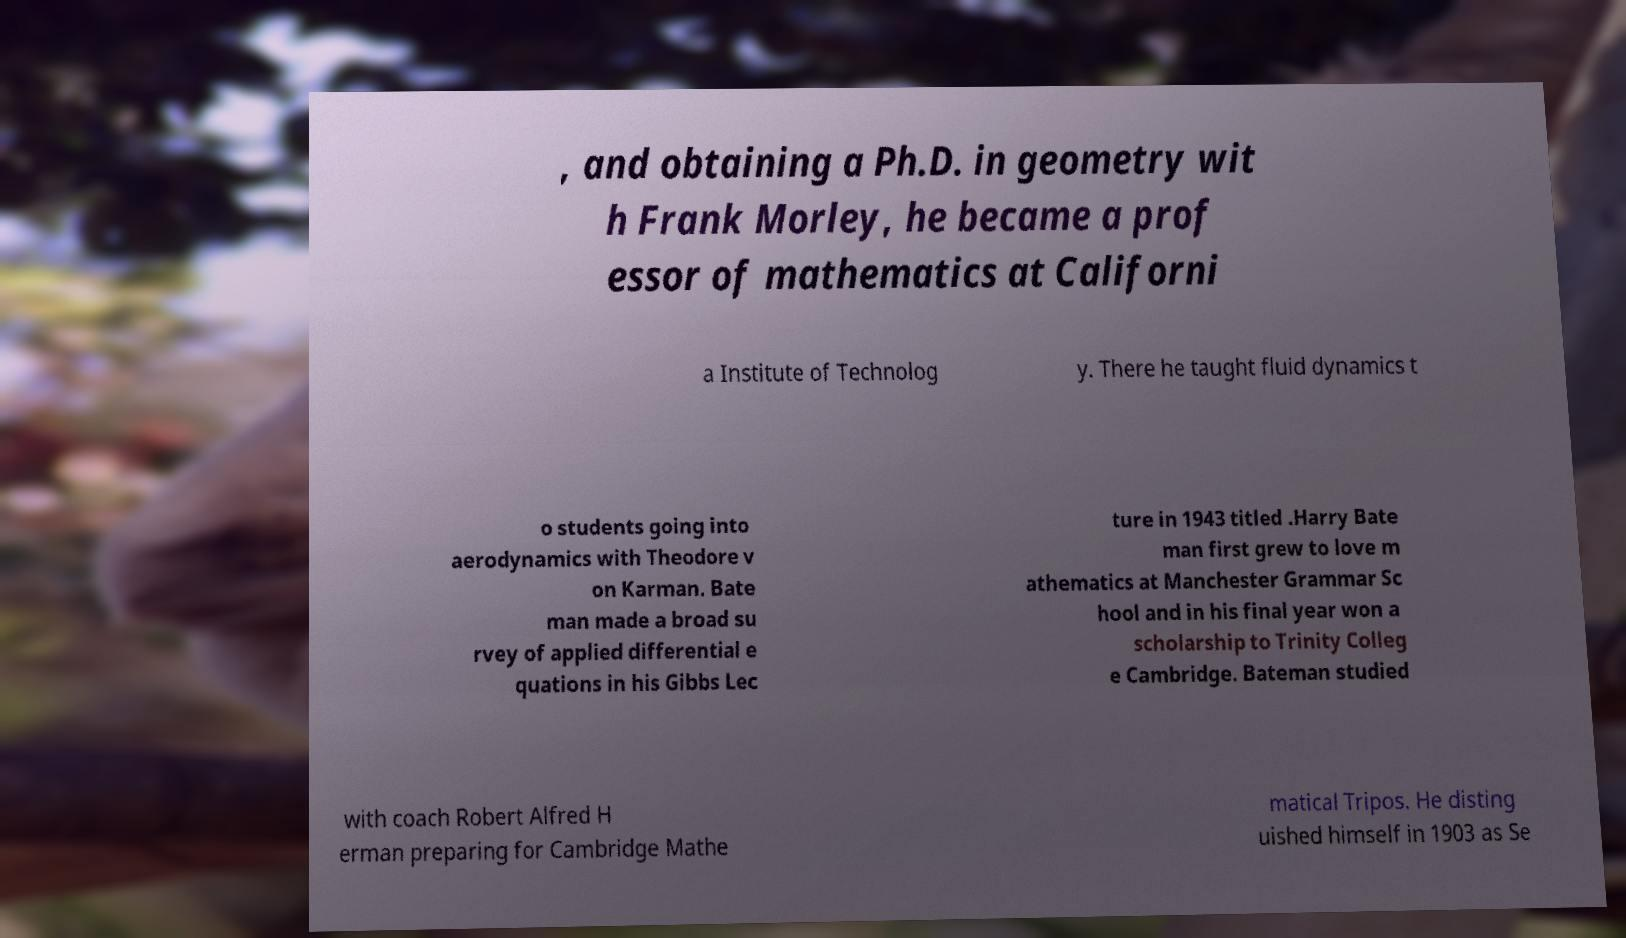Could you extract and type out the text from this image? , and obtaining a Ph.D. in geometry wit h Frank Morley, he became a prof essor of mathematics at Californi a Institute of Technolog y. There he taught fluid dynamics t o students going into aerodynamics with Theodore v on Karman. Bate man made a broad su rvey of applied differential e quations in his Gibbs Lec ture in 1943 titled .Harry Bate man first grew to love m athematics at Manchester Grammar Sc hool and in his final year won a scholarship to Trinity Colleg e Cambridge. Bateman studied with coach Robert Alfred H erman preparing for Cambridge Mathe matical Tripos. He disting uished himself in 1903 as Se 